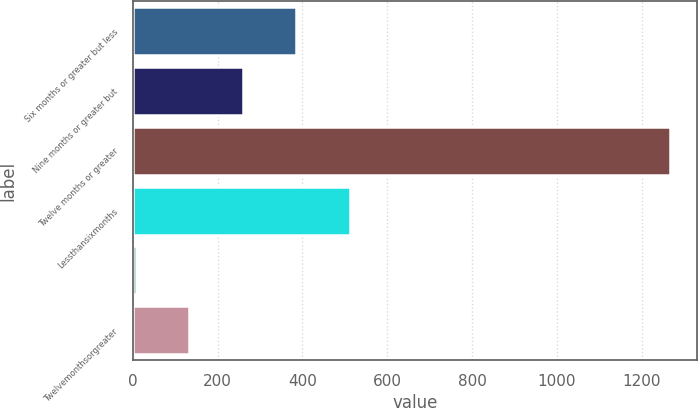Convert chart to OTSL. <chart><loc_0><loc_0><loc_500><loc_500><bar_chart><fcel>Six months or greater but less<fcel>Nine months or greater but<fcel>Twelve months or greater<fcel>Lessthansixmonths<fcel>Unnamed: 4<fcel>Twelvemonthsorgreater<nl><fcel>385<fcel>259<fcel>1267<fcel>511<fcel>7<fcel>133<nl></chart> 